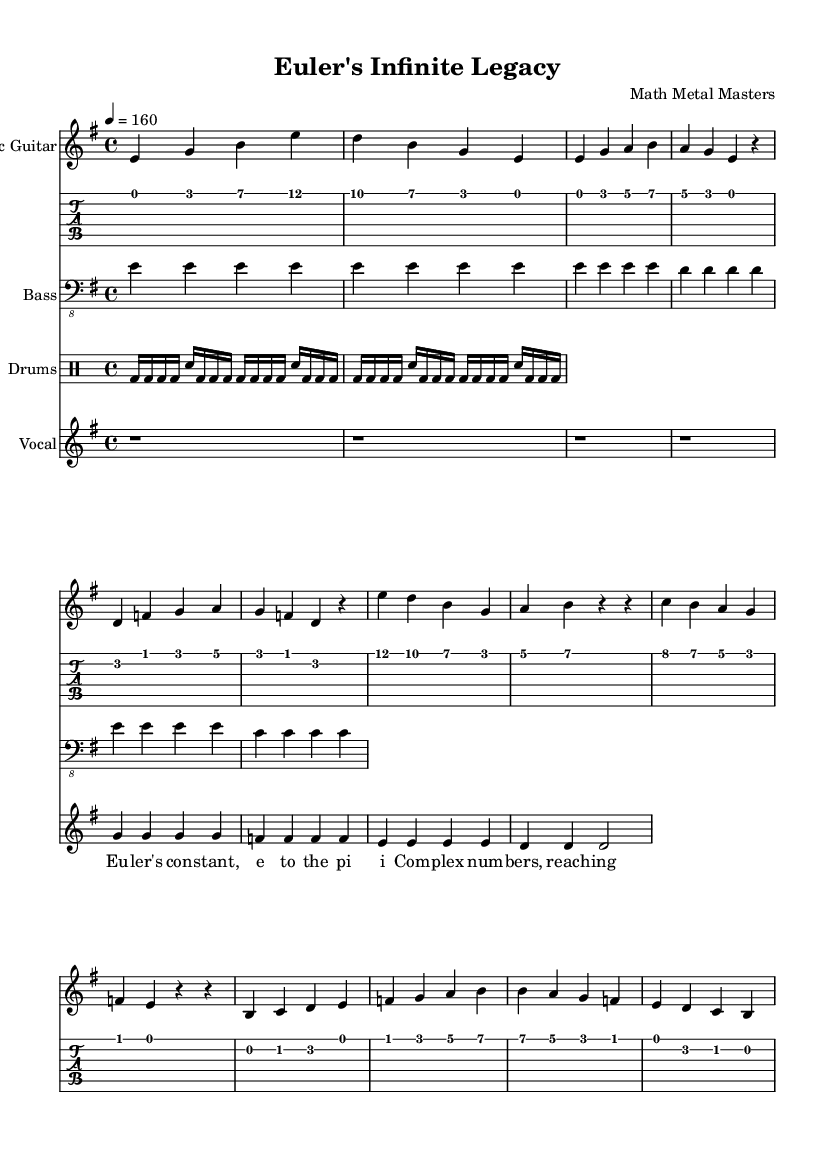What is the title of this piece? The title is found at the top of the sheet music in the header section. It states "Euler's Infinite Legacy."
Answer: Euler's Infinite Legacy What is the key signature of this music? The key signature is indicated right after the word 'global' in the music code. It shows "e minor" which has one sharp (F#).
Answer: e minor What is the time signature of the piece? The time signature is specified right after the key signature in the 'global' section. It is shown as "4/4", meaning there are four beats in each measure and a quarter note gets one beat.
Answer: 4/4 What is the tempo marking in this music? The tempo can be found in the 'global' section, specifically next to the "tempo" directive. It states "4 = 160," indicating that each quarter note is played at a speed of 160 beats per minute.
Answer: 160 How many measures are present in the electric guitar part? To determine the number of measures, we should count the number of bar lines present in the electric guitar music section. There are 4 measures in the electric guitar part.
Answer: 4 What type of guitar is used in this piece? The guitar is indicated by the presence of "electricGuitar" in the code and the instrument label in the score. Thus, it specifies the type clearly as an electric guitar.
Answer: Electric guitar What is the vocal style used in this piece? The vocal part does not include complex rhythms or melodies; it is simple and repetitive, typical of metal; the lyrics are straightforward. Thus, the style can be considered straightforward or melodic.
Answer: Melodic 